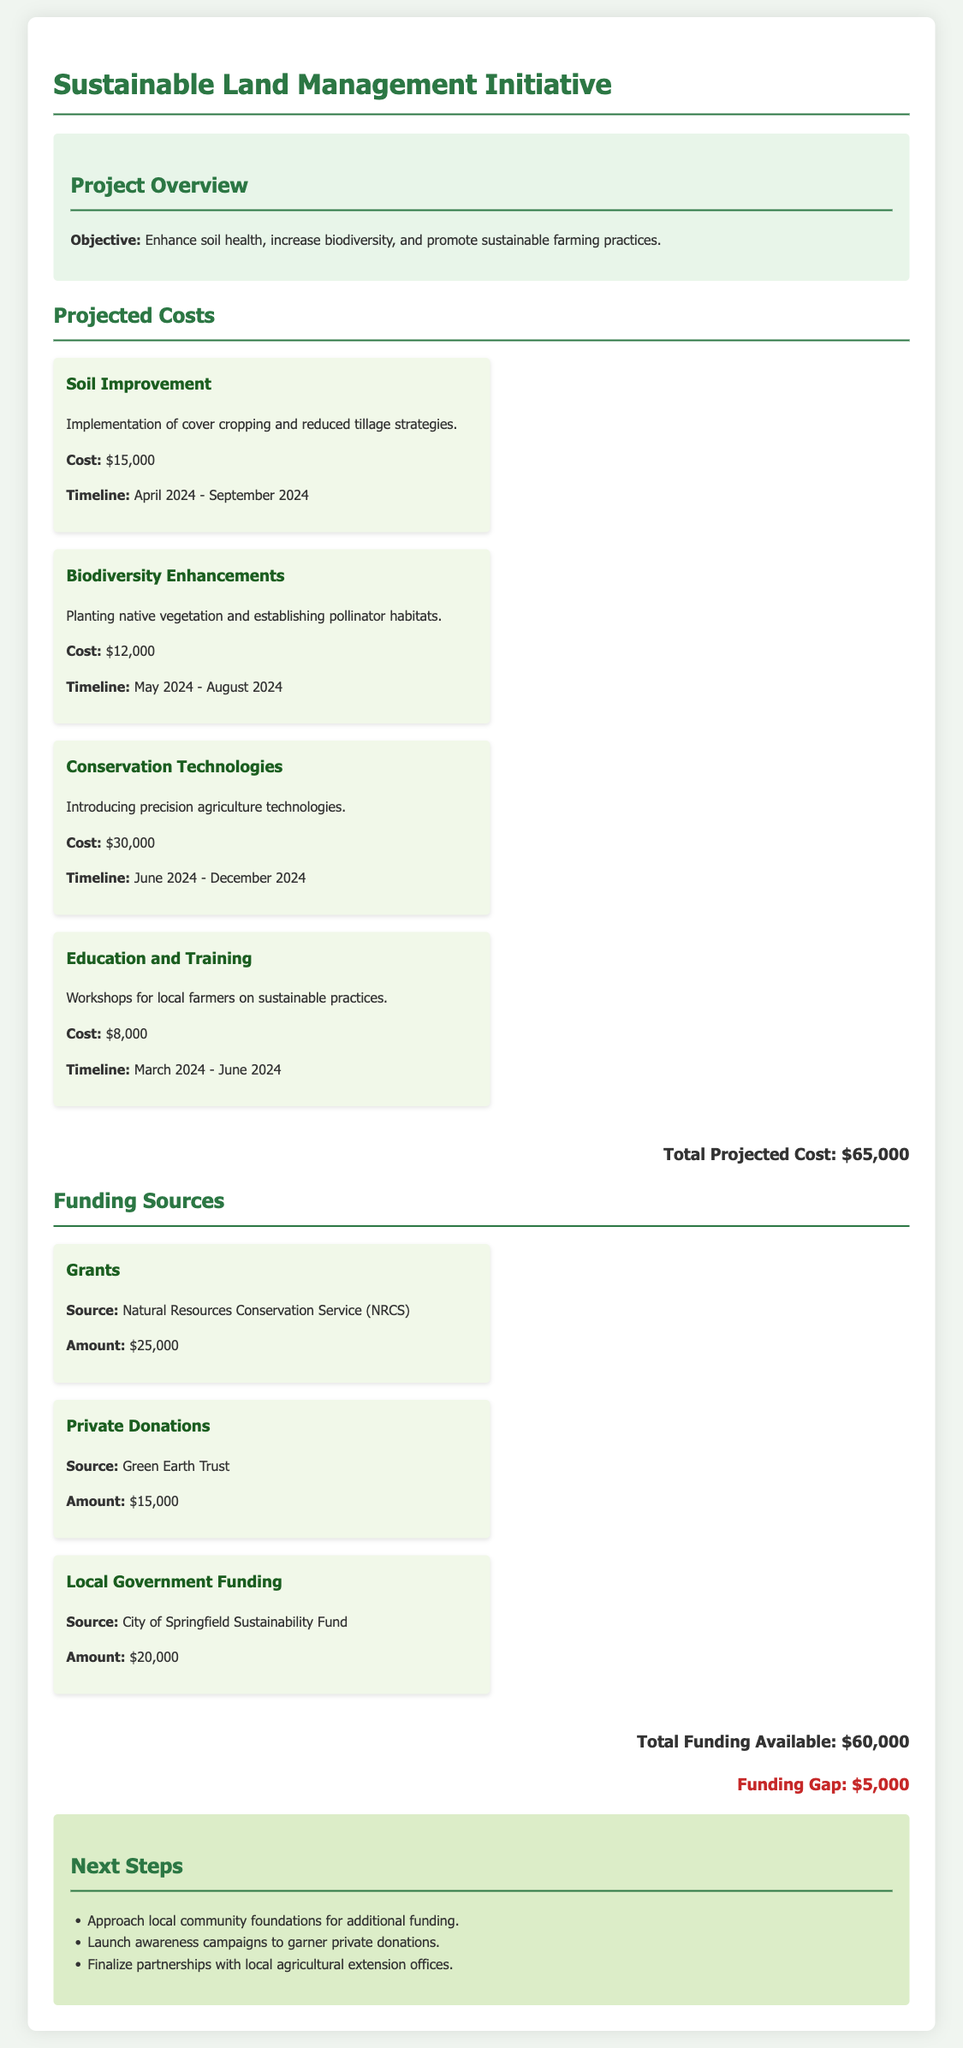what is the objective of the project? The objective is to enhance soil health, increase biodiversity, and promote sustainable farming practices.
Answer: Enhance soil health, increase biodiversity, and promote sustainable farming practices what is the cost of soil improvement? The cost of soil improvement is explicitly stated in the document.
Answer: $15,000 what is the funding gap for the project? The funding gap can be determined by subtracting total funding available from total projected cost.
Answer: $5,000 when does the education and training project start? The start date for the education and training project is mentioned in the timeline.
Answer: March 2024 who is providing private donations for the project? The source of private donations is specified in the funding section.
Answer: Green Earth Trust what is the total projected cost of the project? The total projected cost is listed at the end of the projected costs section.
Answer: $65,000 which conservation technology is introduced? The document specifies the type of technology being introduced in the project.
Answer: Precision agriculture technologies how much funding is provided by the local government? The specific amount provided by the local government is indicated in the funding sources section.
Answer: $20,000 